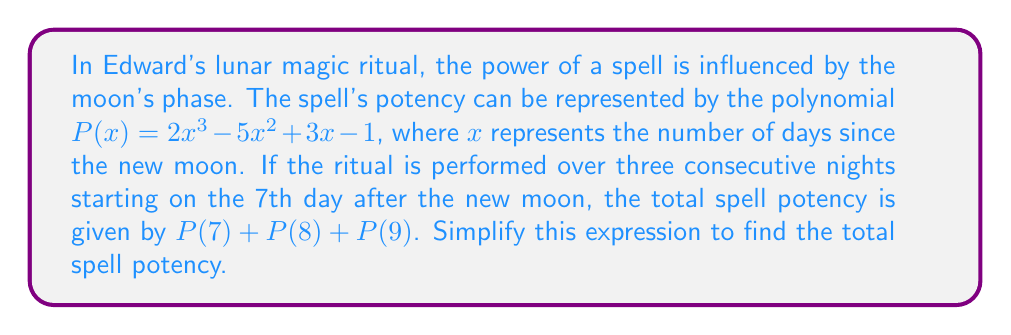Provide a solution to this math problem. To solve this problem, we need to evaluate $P(x)$ for $x = 7$, $x = 8$, and $x = 9$, then add the results.

1. For $P(7)$:
   $P(7) = 2(7^3) - 5(7^2) + 3(7) - 1$
   $= 2(343) - 5(49) + 3(7) - 1$
   $= 686 - 245 + 21 - 1$
   $= 461$

2. For $P(8)$:
   $P(8) = 2(8^3) - 5(8^2) + 3(8) - 1$
   $= 2(512) - 5(64) + 3(8) - 1$
   $= 1024 - 320 + 24 - 1$
   $= 727$

3. For $P(9)$:
   $P(9) = 2(9^3) - 5(9^2) + 3(9) - 1$
   $= 2(729) - 5(81) + 3(9) - 1$
   $= 1458 - 405 + 27 - 1$
   $= 1079$

Now, we add these results:
$P(7) + P(8) + P(9) = 461 + 727 + 1079 = 2267$

Therefore, the total spell potency over the three nights is 2267.
Answer: $2267$ 